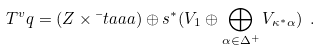Convert formula to latex. <formula><loc_0><loc_0><loc_500><loc_500>T ^ { v } q = ( Z \times \bar { \ } t a a a ) \oplus s ^ { * } ( V _ { 1 } \oplus \bigoplus _ { \alpha \in \Delta ^ { + } } V _ { \kappa ^ { * } \alpha } ) \ .</formula> 